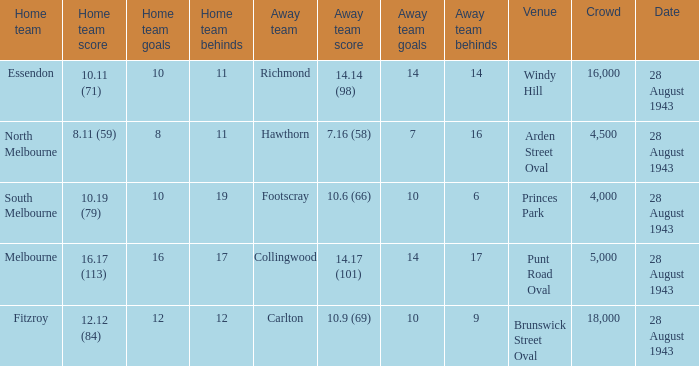What game showed a home team score of 8.11 (59)? 28 August 1943. 